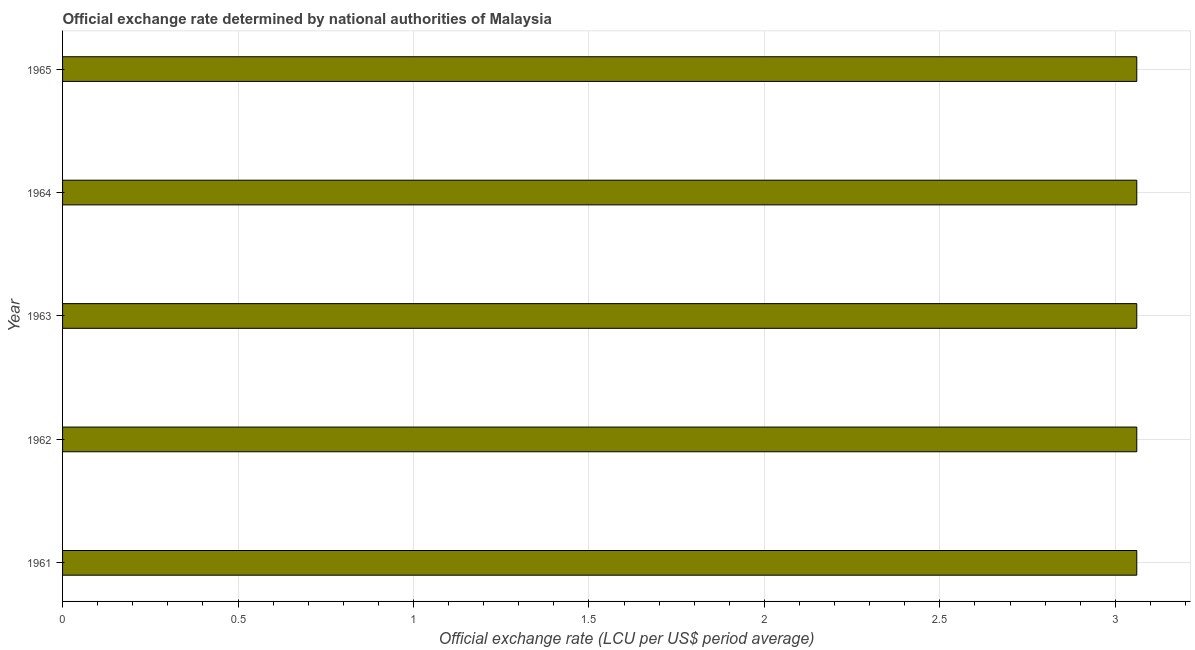Does the graph contain any zero values?
Ensure brevity in your answer.  No. What is the title of the graph?
Offer a terse response. Official exchange rate determined by national authorities of Malaysia. What is the label or title of the X-axis?
Provide a succinct answer. Official exchange rate (LCU per US$ period average). What is the official exchange rate in 1964?
Keep it short and to the point. 3.06. Across all years, what is the maximum official exchange rate?
Your response must be concise. 3.06. Across all years, what is the minimum official exchange rate?
Give a very brief answer. 3.06. In which year was the official exchange rate minimum?
Provide a short and direct response. 1961. What is the sum of the official exchange rate?
Your answer should be compact. 15.31. What is the average official exchange rate per year?
Keep it short and to the point. 3.06. What is the median official exchange rate?
Your answer should be very brief. 3.06. In how many years, is the official exchange rate greater than 0.1 ?
Offer a very short reply. 5. Do a majority of the years between 1961 and 1963 (inclusive) have official exchange rate greater than 2.9 ?
Ensure brevity in your answer.  Yes. Is the official exchange rate in 1961 less than that in 1963?
Provide a succinct answer. No. Is the difference between the official exchange rate in 1962 and 1963 greater than the difference between any two years?
Your response must be concise. Yes. What is the difference between the highest and the second highest official exchange rate?
Ensure brevity in your answer.  0. Is the sum of the official exchange rate in 1961 and 1965 greater than the maximum official exchange rate across all years?
Ensure brevity in your answer.  Yes. What is the difference between the highest and the lowest official exchange rate?
Your answer should be compact. 0. In how many years, is the official exchange rate greater than the average official exchange rate taken over all years?
Offer a very short reply. 0. How many bars are there?
Make the answer very short. 5. Are all the bars in the graph horizontal?
Make the answer very short. Yes. What is the difference between two consecutive major ticks on the X-axis?
Make the answer very short. 0.5. What is the Official exchange rate (LCU per US$ period average) of 1961?
Keep it short and to the point. 3.06. What is the Official exchange rate (LCU per US$ period average) of 1962?
Your response must be concise. 3.06. What is the Official exchange rate (LCU per US$ period average) in 1963?
Offer a terse response. 3.06. What is the Official exchange rate (LCU per US$ period average) in 1964?
Keep it short and to the point. 3.06. What is the Official exchange rate (LCU per US$ period average) of 1965?
Ensure brevity in your answer.  3.06. What is the difference between the Official exchange rate (LCU per US$ period average) in 1961 and 1962?
Ensure brevity in your answer.  0. What is the difference between the Official exchange rate (LCU per US$ period average) in 1961 and 1964?
Provide a short and direct response. 0. What is the difference between the Official exchange rate (LCU per US$ period average) in 1961 and 1965?
Make the answer very short. 0. What is the difference between the Official exchange rate (LCU per US$ period average) in 1962 and 1964?
Your response must be concise. 0. What is the difference between the Official exchange rate (LCU per US$ period average) in 1963 and 1964?
Provide a short and direct response. 0. What is the ratio of the Official exchange rate (LCU per US$ period average) in 1961 to that in 1962?
Your answer should be very brief. 1. What is the ratio of the Official exchange rate (LCU per US$ period average) in 1963 to that in 1964?
Your answer should be very brief. 1. What is the ratio of the Official exchange rate (LCU per US$ period average) in 1963 to that in 1965?
Keep it short and to the point. 1. What is the ratio of the Official exchange rate (LCU per US$ period average) in 1964 to that in 1965?
Your response must be concise. 1. 